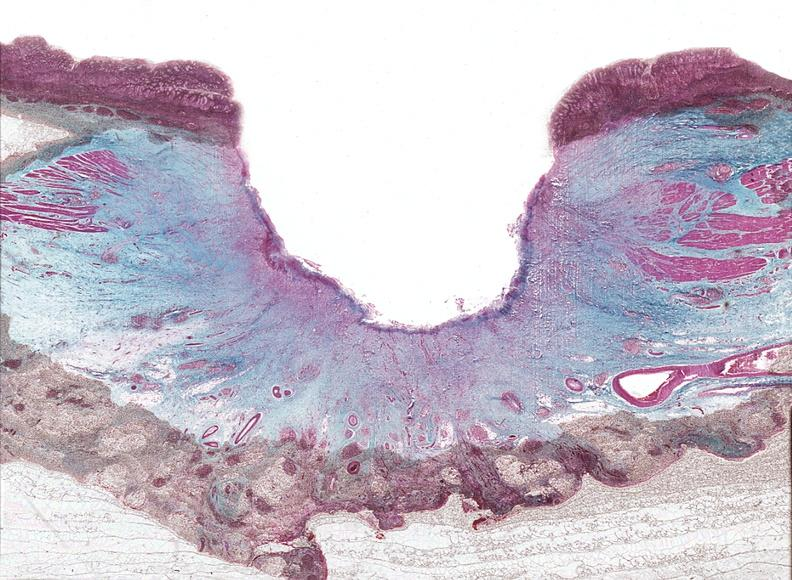s fibrinous peritonitis present?
Answer the question using a single word or phrase. No 